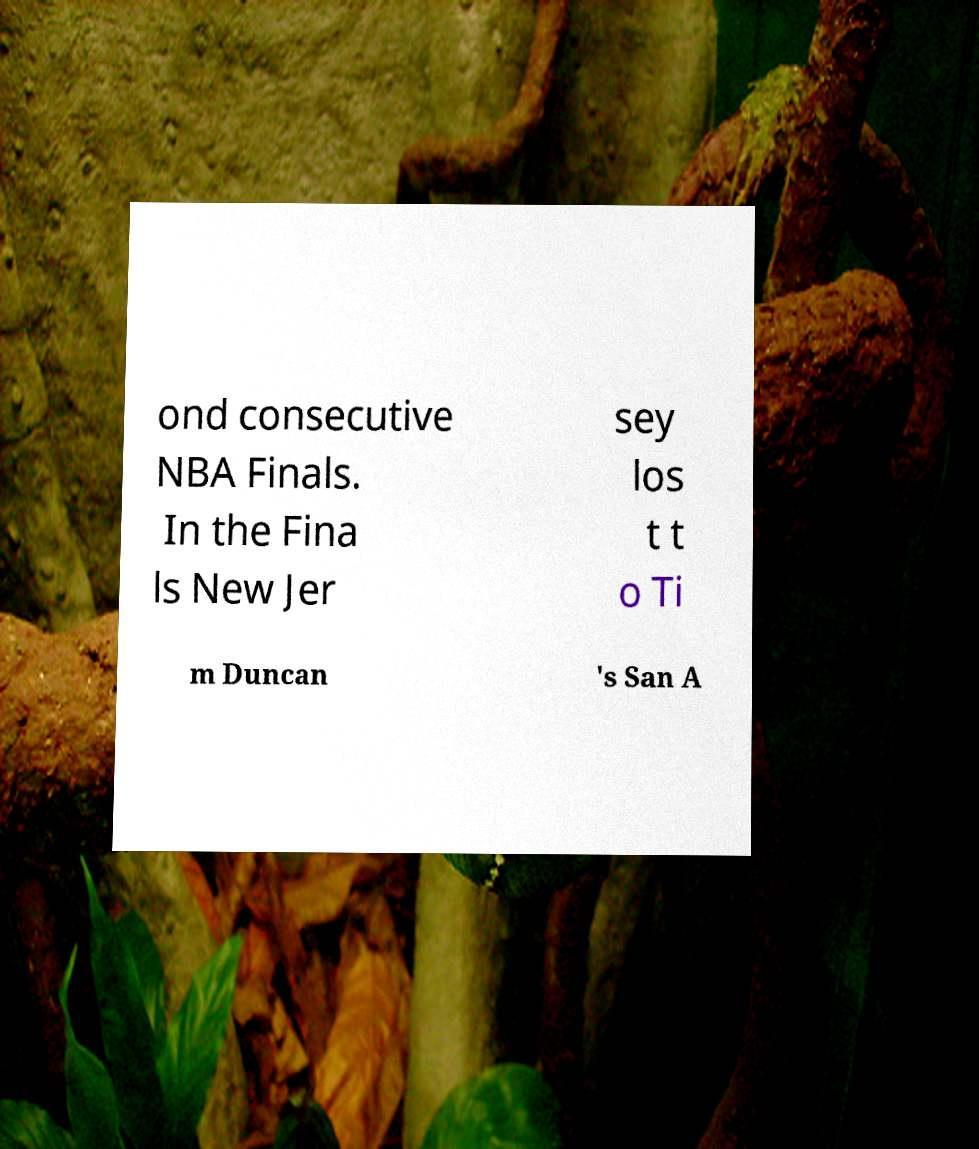Can you read and provide the text displayed in the image?This photo seems to have some interesting text. Can you extract and type it out for me? ond consecutive NBA Finals. In the Fina ls New Jer sey los t t o Ti m Duncan 's San A 